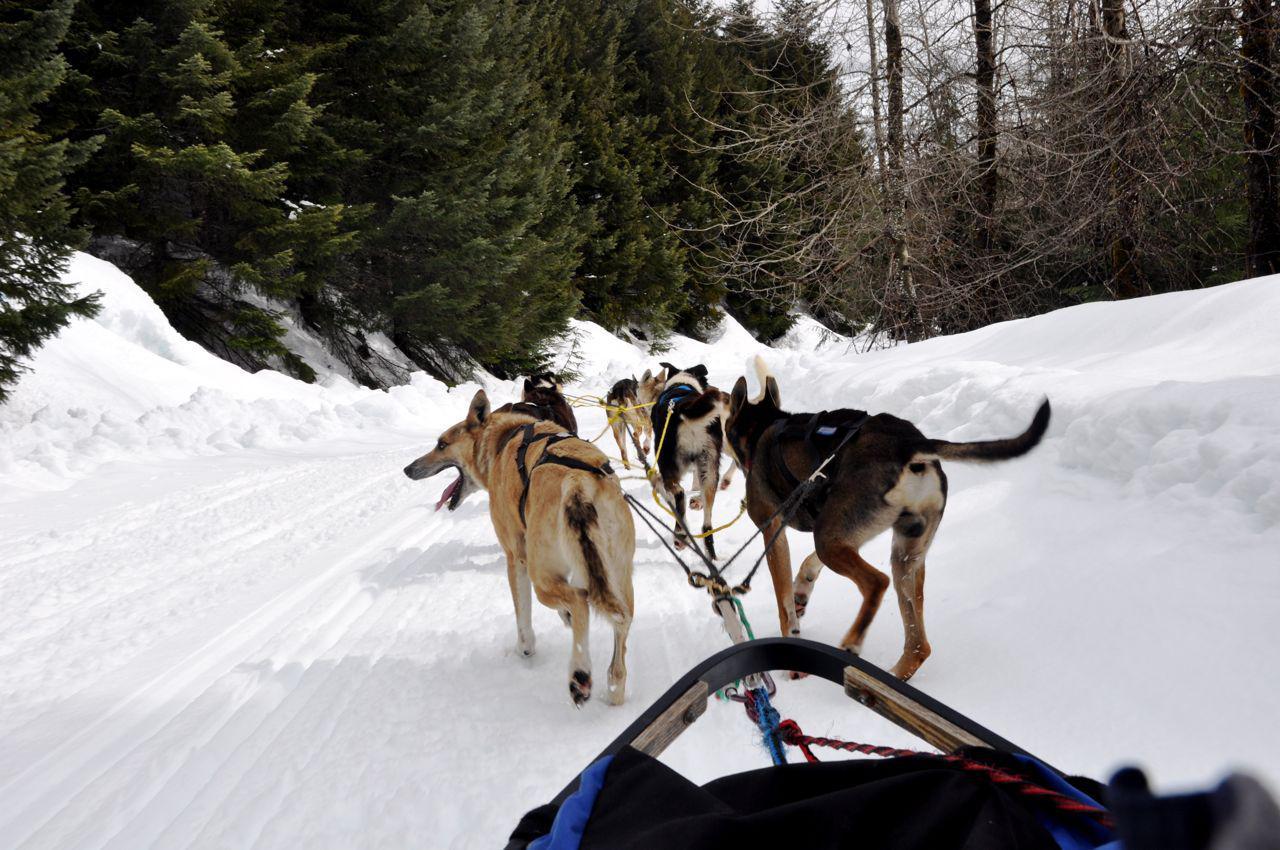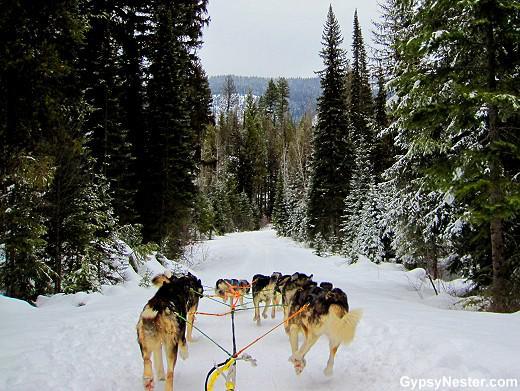The first image is the image on the left, the second image is the image on the right. Given the left and right images, does the statement "Each image includes a sled dog team facing away from the camera toward a trail lined with trees." hold true? Answer yes or no. Yes. The first image is the image on the left, the second image is the image on the right. Considering the images on both sides, is "In one of the images, at least eight sled dogs are resting in the snow." valid? Answer yes or no. No. 